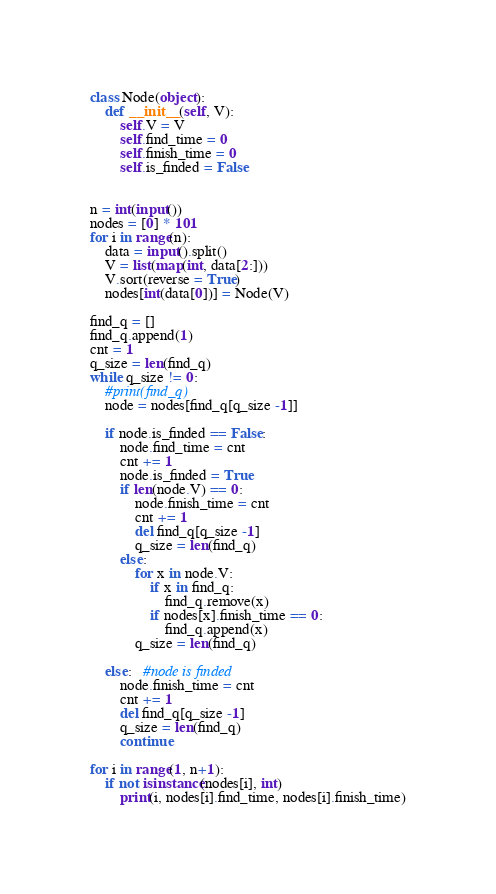<code> <loc_0><loc_0><loc_500><loc_500><_Python_>class Node(object):
    def __init__(self, V):
        self.V = V
        self.find_time = 0
        self.finish_time = 0
        self.is_finded = False


n = int(input())
nodes = [0] * 101
for i in range(n):
    data = input().split()
    V = list(map(int, data[2:]))
    V.sort(reverse = True)
    nodes[int(data[0])] = Node(V)

find_q = []
find_q.append(1)
cnt = 1
q_size = len(find_q)
while q_size != 0:
    #print(find_q)
    node = nodes[find_q[q_size -1]]

    if node.is_finded == False:
        node.find_time = cnt
        cnt += 1
        node.is_finded = True
        if len(node.V) == 0:
            node.finish_time = cnt
            cnt += 1
            del find_q[q_size -1]
            q_size = len(find_q)
        else:
            for x in node.V:
                if x in find_q:
                    find_q.remove(x)
                if nodes[x].finish_time == 0: 
                    find_q.append(x)
            q_size = len(find_q)

    else:   #node is finded
        node.finish_time = cnt
        cnt += 1
        del find_q[q_size -1]
        q_size = len(find_q)
        continue

for i in range(1, n+1):
    if not isinstance(nodes[i], int)
        print(i, nodes[i].find_time, nodes[i].finish_time)</code> 